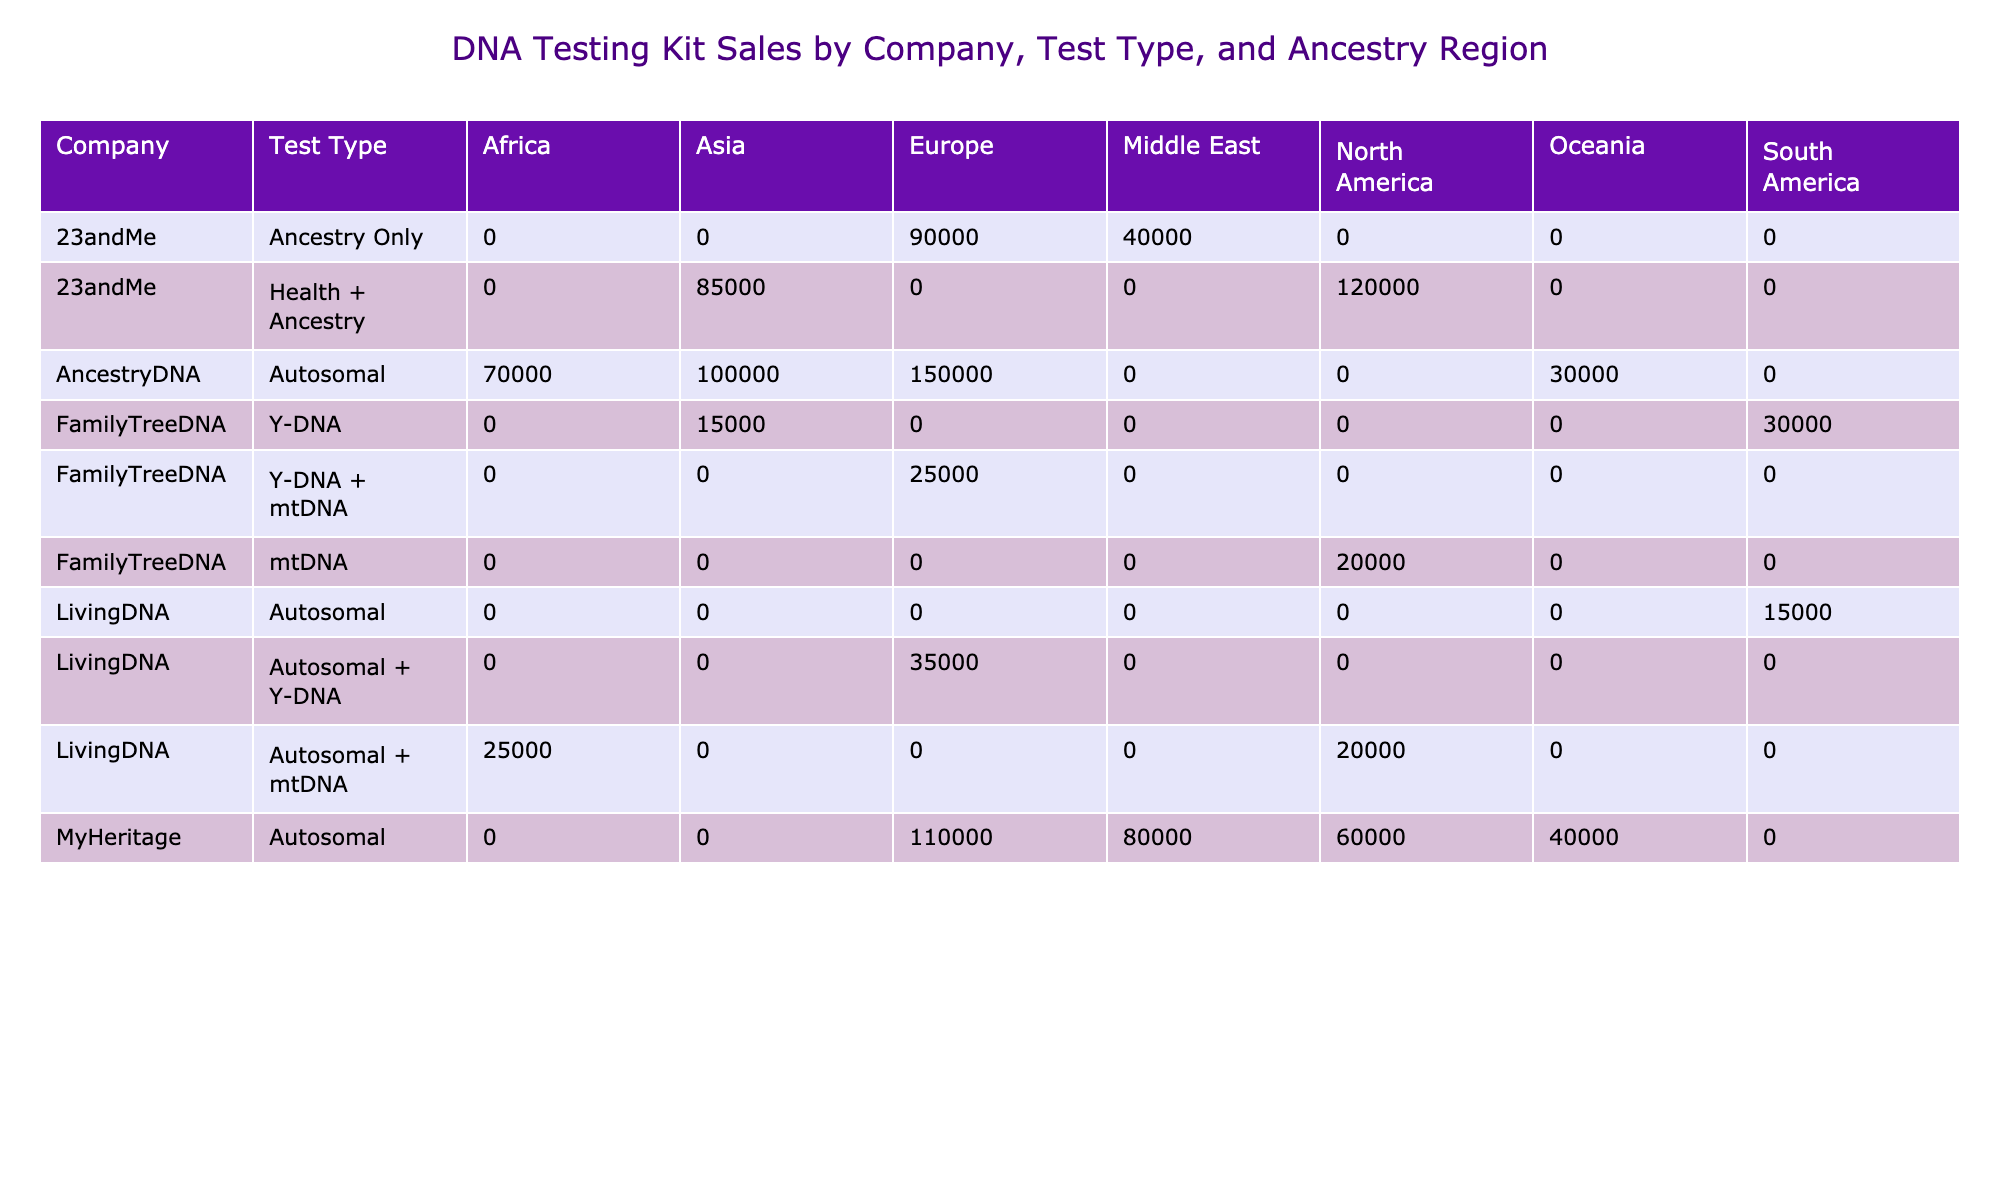What company sold the most DNA testing kits in Europe? By examining the units sold under the "Europe" column, AncestryDNA shows the highest number at 150,000 compared to other companies.
Answer: AncestryDNA Which type of test sold the least in South America? Reviewing the South America column, LivingDNA’s Autosomal test sold 15,000 units, which is less than FamilyTreeDNA’s Y-DNA test that sold 30,000 units.
Answer: Autosomal What is the total number of units sold for MyHeritage in North America? Adding the units sold for MyHeritage in North America from the table, which is 60,000 from the Autosomal test. There’s no other test listed for this region for MyHeritage, so the total remains 60,000.
Answer: 60000 Did FamilyTreeDNA offer an autosomal test in Asia? Looking at the Asia column for FamilyTreeDNA, there is no entry for an autosomal test; it only sold Y-DNA which confirms the answer.
Answer: No Which company had a higher sales figure for autosomal tests in Africa, AncestryDNA or LivingDNA? In the Africa column, AncestryDNA sold 70,000 units, while LivingDNA sold only 25,000 units for the autosomal test. This demonstrates that AncestryDNA had a higher sales figure.
Answer: AncestryDNA What is the average price of the Health + Ancestry test type from all companies? The only companies offering a Health + Ancestry test are 23andMe and 23andMe again for Asia, both at an average price of 199. The average price is calculated at 199 since they're both the same.
Answer: 199 How many more units did AncestryDNA sell in Asia compared to FamilyTreeDNA in Asia? AncestryDNA sold 100,000 units in Asia while FamilyTreeDNA sold 15,000 units for the Y-DNA test. Subtracting gives us 100,000 - 15,000 = 85,000 additional units sold by AncestryDNA.
Answer: 85000 Which test type generated the highest revenue for living DNA in Europe? LivingDNA sold the Autosomal + Y-DNA test in Europe for 35,000 units at an average price of 159, yielding a revenue of 5,565,000. No other test types are recorded for LivingDNA in that region, thus making it the highest.
Answer: Autosomal + Y-DNA How many total units were sold for the mtDNA test across all companies? The mtDNA test has only one recorded entry from FamilyTreeDNA at 20,000 units in North America. Therefore, the total units sold for the mtDNA test across all companies is 20,000.
Answer: 20000 